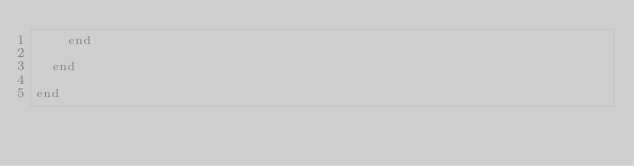Convert code to text. <code><loc_0><loc_0><loc_500><loc_500><_Ruby_>    end

  end

end</code> 